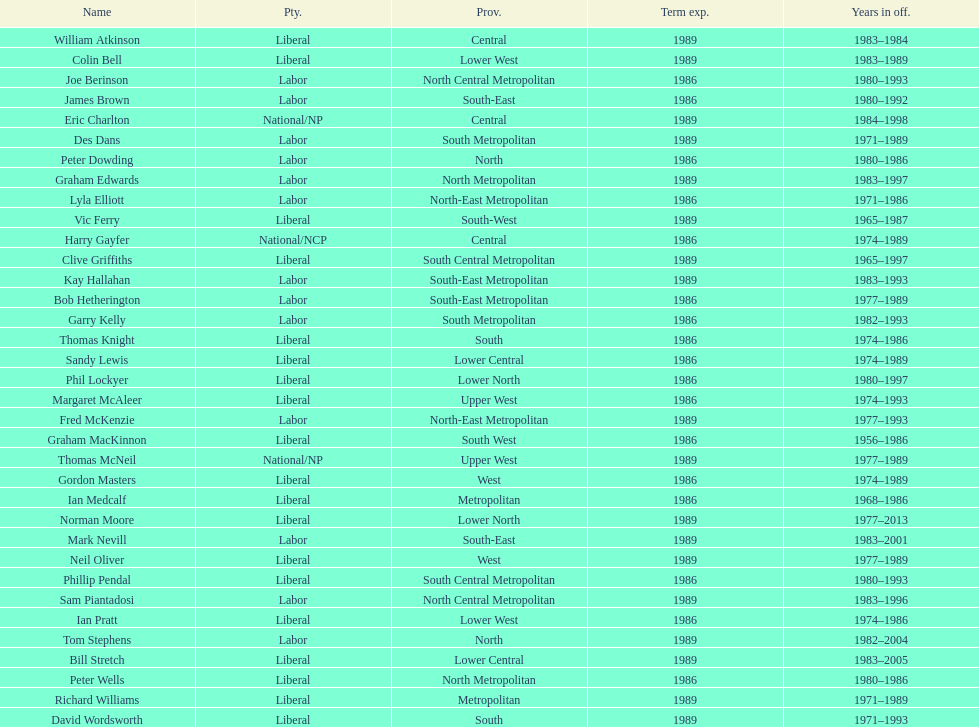What is the total number of members whose term expires in 1989? 9. 